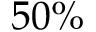<formula> <loc_0><loc_0><loc_500><loc_500>5 0 \%</formula> 